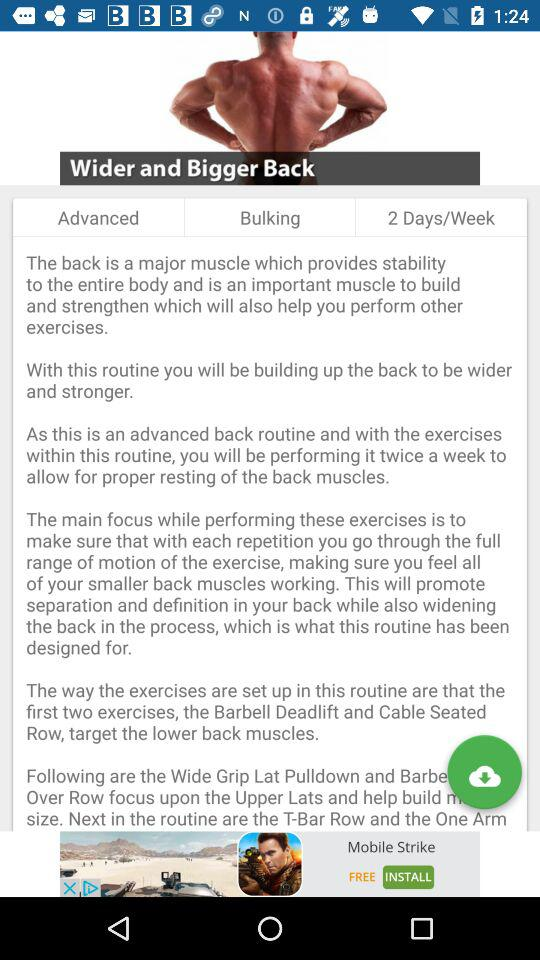How many days a week is this routine performed?
Answer the question using a single word or phrase. 2 